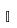Convert formula to latex. <formula><loc_0><loc_0><loc_500><loc_500>\mathbb { I }</formula> 